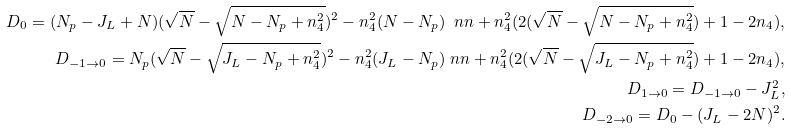Convert formula to latex. <formula><loc_0><loc_0><loc_500><loc_500>D _ { 0 } = ( N _ { p } - J _ { L } + N ) ( \sqrt { N } - \sqrt { N - N _ { p } + n _ { 4 } ^ { 2 } } ) ^ { 2 } - n _ { 4 } ^ { 2 } ( N - N _ { p } ) \ n n + n _ { 4 } ^ { 2 } ( 2 ( \sqrt { N } - \sqrt { N - N _ { p } + n _ { 4 } ^ { 2 } } ) + 1 - 2 n _ { 4 } ) , \\ D _ { - 1 \to 0 } = N _ { p } ( \sqrt { N } - \sqrt { J _ { L } - N _ { p } + n _ { 4 } ^ { 2 } } ) ^ { 2 } - n _ { 4 } ^ { 2 } ( J _ { L } - N _ { p } ) \ n n + n _ { 4 } ^ { 2 } ( 2 ( \sqrt { N } - \sqrt { J _ { L } - N _ { p } + n _ { 4 } ^ { 2 } } ) + 1 - 2 n _ { 4 } ) , \\ D _ { 1 \to 0 } = D _ { - 1 \to 0 } - J _ { L } ^ { 2 } , \\ D _ { - 2 \to 0 } = D _ { 0 } - ( J _ { L } - 2 N ) ^ { 2 } .</formula> 